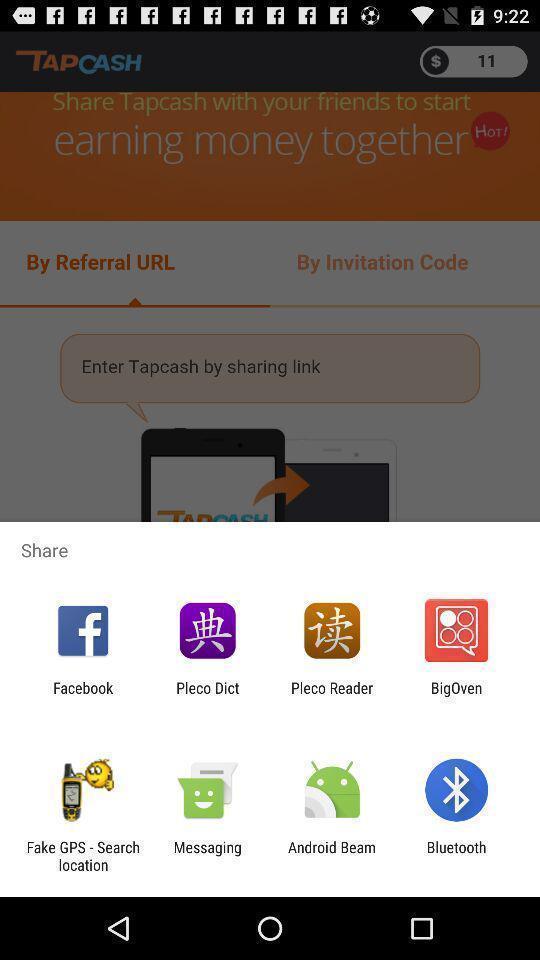Tell me what you see in this picture. Pop-up showing different kinds of sharing options. 